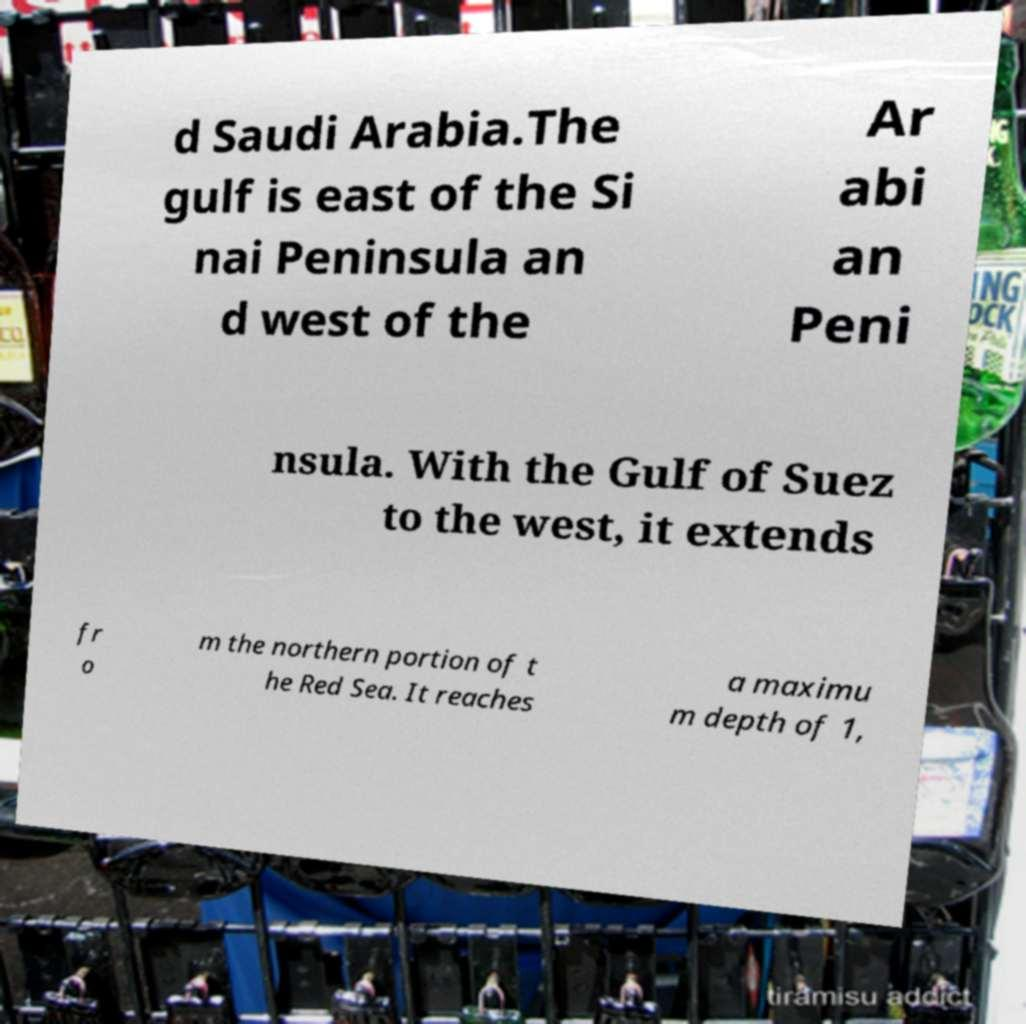Can you accurately transcribe the text from the provided image for me? d Saudi Arabia.The gulf is east of the Si nai Peninsula an d west of the Ar abi an Peni nsula. With the Gulf of Suez to the west, it extends fr o m the northern portion of t he Red Sea. It reaches a maximu m depth of 1, 